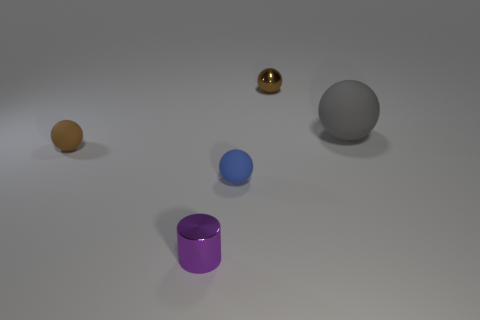What different shapes can be seen in the image? The image shows objects with various shapes: a cylindrical purple object, a spherical grey object, a spherical gold object, and two spheroids - one yellow and one blue. 